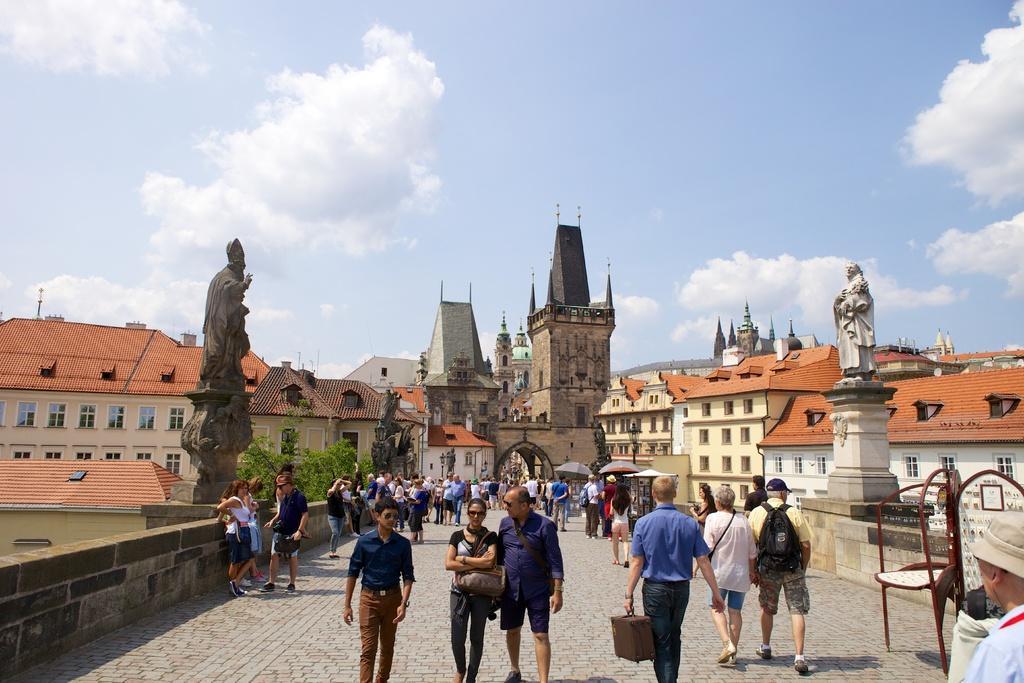Please provide a concise description of this image. In this picture there are people in the center of the image and there are statues on the right and left side of the image, there are buildings in the background area of the image, there is boundary on the right and left side of the image. 